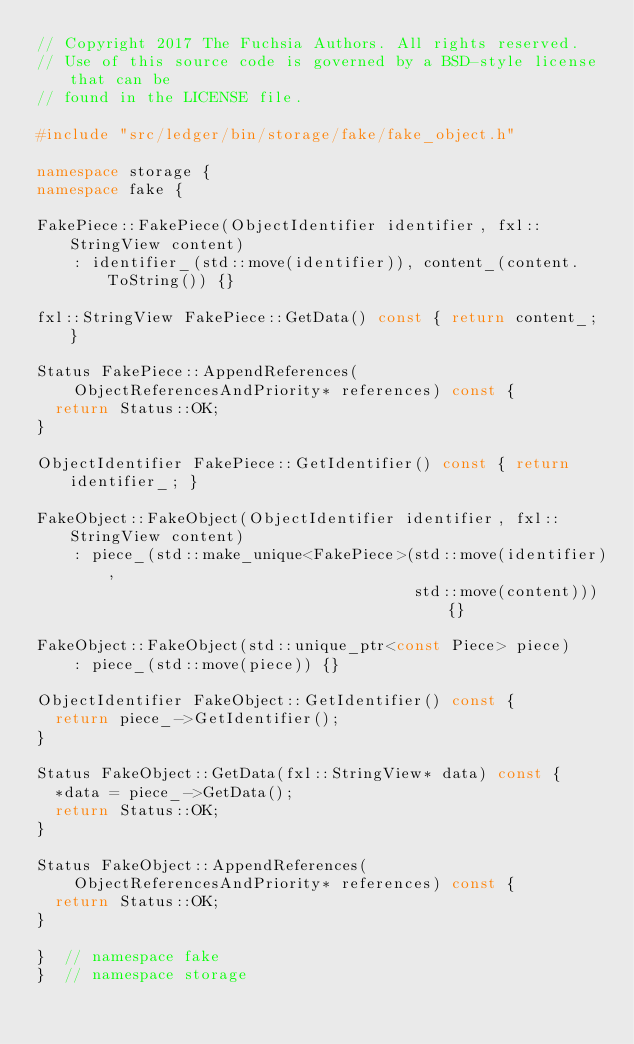<code> <loc_0><loc_0><loc_500><loc_500><_C++_>// Copyright 2017 The Fuchsia Authors. All rights reserved.
// Use of this source code is governed by a BSD-style license that can be
// found in the LICENSE file.

#include "src/ledger/bin/storage/fake/fake_object.h"

namespace storage {
namespace fake {

FakePiece::FakePiece(ObjectIdentifier identifier, fxl::StringView content)
    : identifier_(std::move(identifier)), content_(content.ToString()) {}

fxl::StringView FakePiece::GetData() const { return content_; }

Status FakePiece::AppendReferences(
    ObjectReferencesAndPriority* references) const {
  return Status::OK;
}

ObjectIdentifier FakePiece::GetIdentifier() const { return identifier_; }

FakeObject::FakeObject(ObjectIdentifier identifier, fxl::StringView content)
    : piece_(std::make_unique<FakePiece>(std::move(identifier),
                                         std::move(content))) {}

FakeObject::FakeObject(std::unique_ptr<const Piece> piece)
    : piece_(std::move(piece)) {}

ObjectIdentifier FakeObject::GetIdentifier() const {
  return piece_->GetIdentifier();
}

Status FakeObject::GetData(fxl::StringView* data) const {
  *data = piece_->GetData();
  return Status::OK;
}

Status FakeObject::AppendReferences(
    ObjectReferencesAndPriority* references) const {
  return Status::OK;
}

}  // namespace fake
}  // namespace storage
</code> 